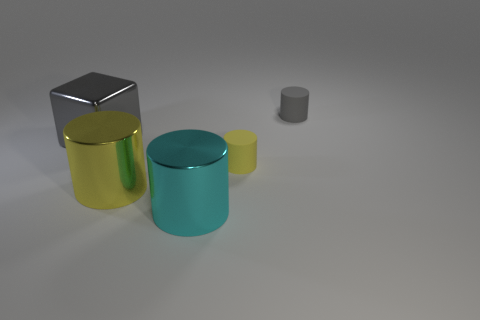Add 3 cyan metal cylinders. How many objects exist? 8 Subtract all cylinders. How many objects are left? 1 Subtract 0 red cubes. How many objects are left? 5 Subtract all small red things. Subtract all shiny cylinders. How many objects are left? 3 Add 4 small yellow rubber things. How many small yellow rubber things are left? 5 Add 4 big yellow balls. How many big yellow balls exist? 4 